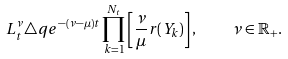Convert formula to latex. <formula><loc_0><loc_0><loc_500><loc_500>L ^ { \nu } _ { t } \triangle q e ^ { - ( \nu - \mu ) t } \prod _ { k = 1 } ^ { N _ { t } } \left [ \frac { \nu } { \mu } r ( Y _ { k } ) \right ] , \quad \nu \in \mathbb { R _ { + } } .</formula> 